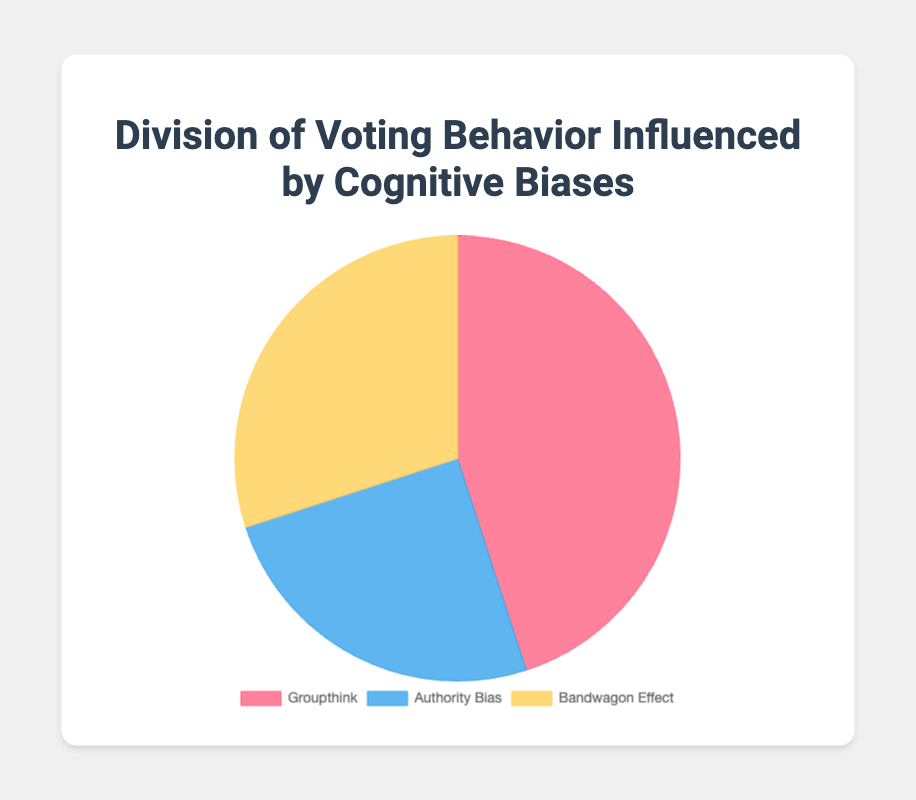what percentage of votes are influenced by groupthink and bandwagon effect combined? To calculate the combined percentage, sum the percentages influenced by groupthink and bandwagon effect: 45% (groupthink) + 30% (bandwagon effect) = 75%.
Answer: 75% which cognitive bias has the least influence on voting behavior? Compared to groupthink (45%) and bandwagon effect (30%), authority bias has the lowest influence with 25%.
Answer: authority bias is the influence of groupthink greater than the combined influence of authority bias and bandwagon effect? The influence of groupthink is 45%. The combined influence of authority bias and bandwagon effect is 25% + 30% = 55%. Since 45% < 55%, the influence of groupthink is not greater.
Answer: no what fraction of the votes are influenced by bandwagon effect? The percentage of votes influenced by bandwagon effect is 30%, which can be expressed as the fraction 30/100, simplifying to 3/10.
Answer: 3/10 what is the difference in percentage between the cognitive bias with the highest influence and the one with the lowest? The highest influence is groupthink at 45%, and the lowest influence is authority bias at 25%. The difference is 45% - 25% = 20%.
Answer: 20% what percentage of votes are not influenced by bandwagon effect? If 30% of votes are influenced by the bandwagon effect, then 100% - 30% = 70% of votes are not influenced by it.
Answer: 70% which color represents the authority bias in the pie chart? The pie chart uses blue to represent the authority bias.
Answer: blue if the total number of votes is 200, how many votes are influenced by groupthink? To find the number of votes influenced by groupthink, calculate 45% of 200. This is (45/100) * 200 = 90 votes.
Answer: 90 